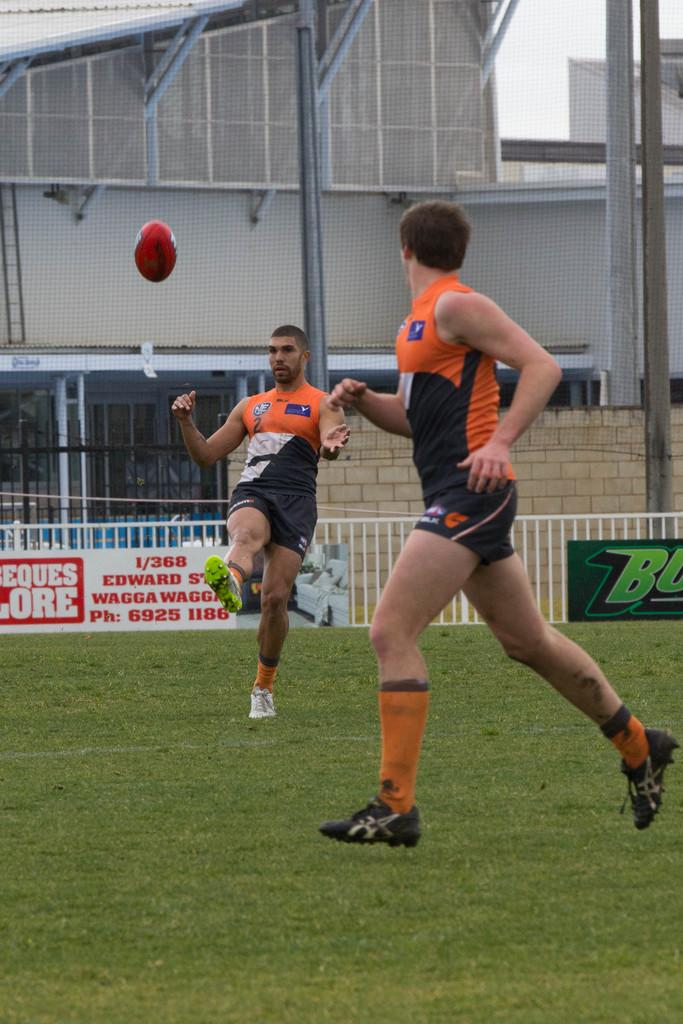How many people are in the image? There are two persons on the ground in the image. What object can be seen in the image that is commonly used in sports and games? There is a ball in the image. What type of barrier is present in the image? There is a fence in the image. Can you describe the signs or messages near the fence in the image? There are boards with text near the railing in the image. What can be seen in the distance in the image? There are buildings in the background of the image. What other object can be seen in the background of the image? There is a ladder in the background of the image. What part of the natural environment is visible in the image? The sky is visible in the background of the image. Can you tell me how many twigs are being used by the persons in the image? There are no twigs present in the image; the persons are not using any twigs. How does the fence touch the sky in the image? The fence does not touch the sky in the image; it is a separate object in the foreground. 